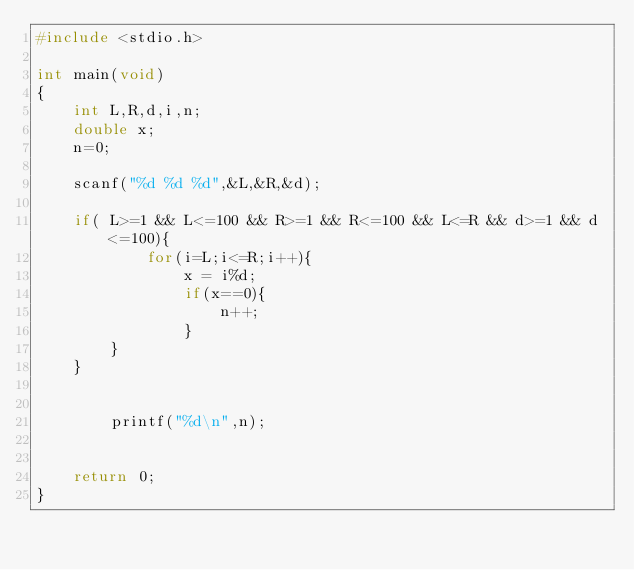<code> <loc_0><loc_0><loc_500><loc_500><_C_>#include <stdio.h>

int main(void)
{
    int L,R,d,i,n;
    double x;
    n=0;

    scanf("%d %d %d",&L,&R,&d);
    
    if( L>=1 && L<=100 && R>=1 && R<=100 && L<=R && d>=1 && d<=100){
            for(i=L;i<=R;i++){
                x = i%d;
                if(x==0){
                    n++;
                }
        }
    }


        printf("%d\n",n);


    return 0;
}</code> 